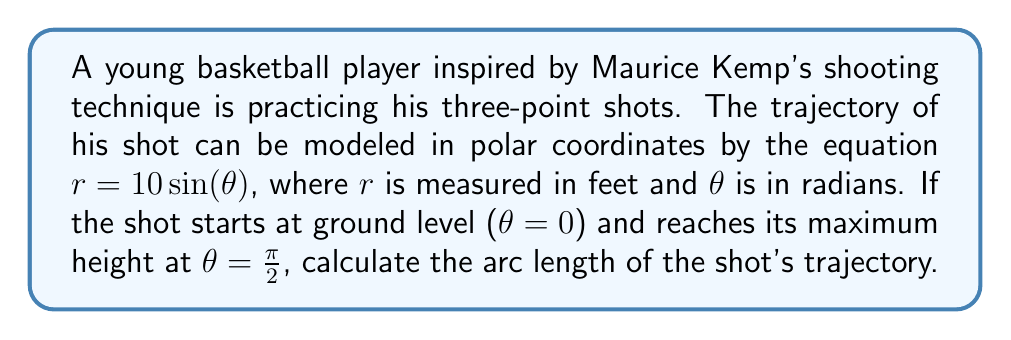What is the answer to this math problem? To solve this problem, we'll use the formula for arc length in polar coordinates:

$$ L = \int_a^b \sqrt{r^2 + \left(\frac{dr}{d\theta}\right)^2} d\theta $$

Where $L$ is the arc length, $r$ is the polar function, and $a$ and $b$ are the starting and ending angles respectively.

Given:
- $r = 10\sin(\theta)$
- $a = 0$ and $b = \frac{\pi}{2}$

Step 1: Find $\frac{dr}{d\theta}$
$$ \frac{dr}{d\theta} = 10\cos(\theta) $$

Step 2: Calculate $r^2 + \left(\frac{dr}{d\theta}\right)^2$
$$ r^2 + \left(\frac{dr}{d\theta}\right)^2 = (10\sin(\theta))^2 + (10\cos(\theta))^2 = 100\sin^2(\theta) + 100\cos^2(\theta) = 100(\sin^2(\theta) + \cos^2(\theta)) = 100 $$

Step 3: Simplify the integrand
$$ \sqrt{r^2 + \left(\frac{dr}{d\theta}\right)^2} = \sqrt{100} = 10 $$

Step 4: Set up and evaluate the integral
$$ L = \int_0^{\frac{\pi}{2}} 10 d\theta = 10\theta \bigg|_0^{\frac{\pi}{2}} = 10 \cdot \frac{\pi}{2} - 10 \cdot 0 = 5\pi $$

Therefore, the arc length of the shot's trajectory is $5\pi$ feet.
Answer: $5\pi$ feet 